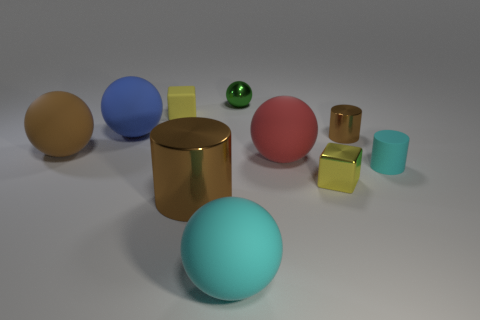Are there more large cyan rubber balls that are in front of the big metallic cylinder than rubber balls behind the large red object?
Provide a short and direct response. No. Does the metal cube have the same color as the metallic cylinder in front of the brown rubber object?
Your answer should be compact. No. What is the material of the brown cylinder that is the same size as the cyan matte ball?
Your response must be concise. Metal. What number of objects are red rubber balls or cylinders right of the large cyan rubber sphere?
Provide a short and direct response. 3. There is a yellow metal thing; does it have the same size as the cyan thing that is in front of the rubber cylinder?
Keep it short and to the point. No. How many cubes are either gray matte things or big blue objects?
Ensure brevity in your answer.  0. What number of large matte balls are in front of the blue rubber sphere and to the right of the brown rubber ball?
Keep it short and to the point. 2. How many other things are there of the same color as the metallic cube?
Offer a terse response. 1. What is the shape of the brown object in front of the red object?
Your answer should be very brief. Cylinder. Are the brown ball and the small brown object made of the same material?
Offer a very short reply. No. 